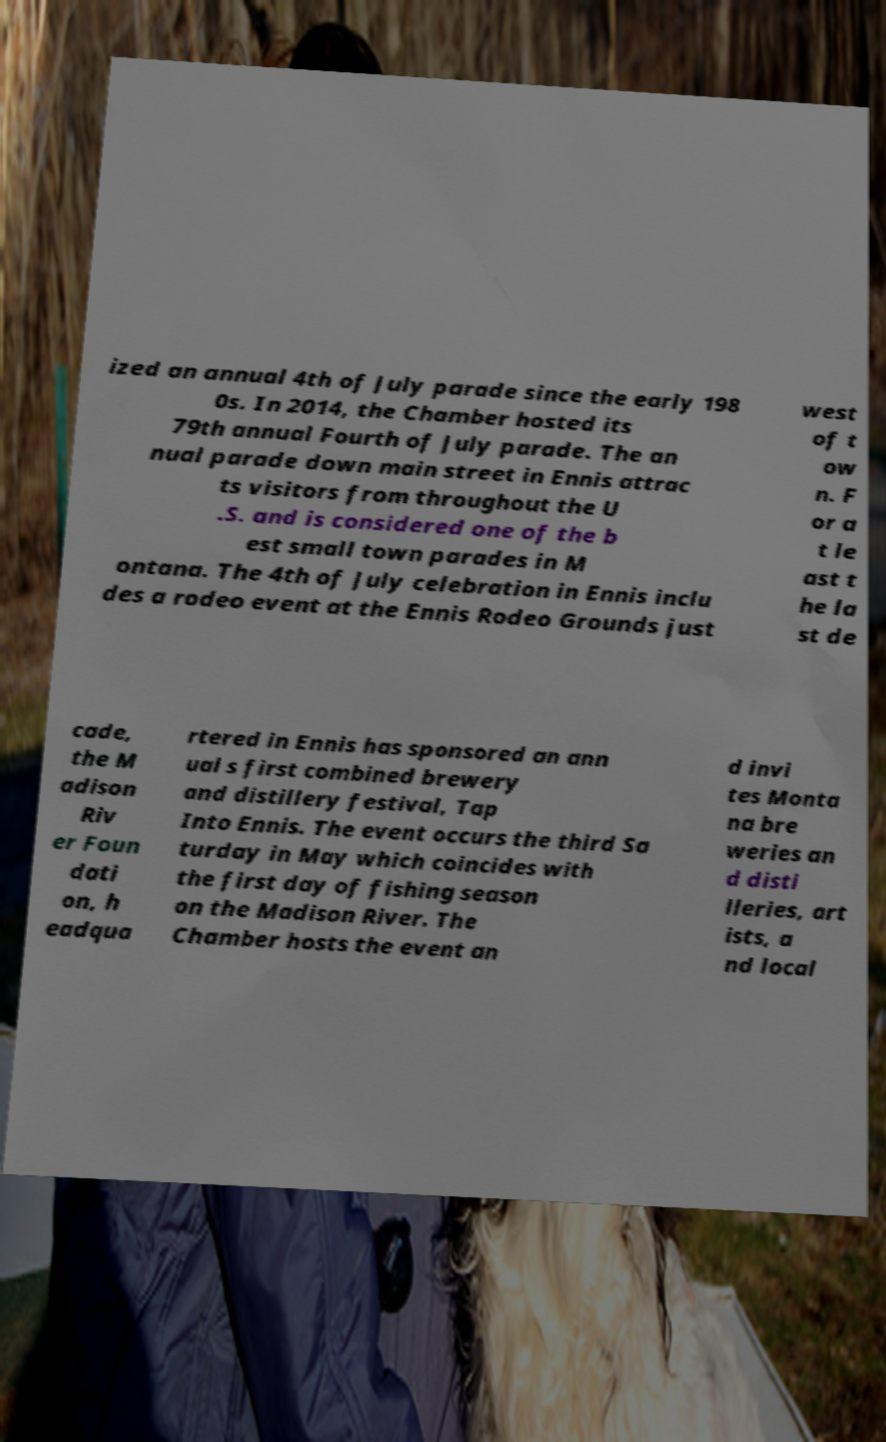Please read and relay the text visible in this image. What does it say? ized an annual 4th of July parade since the early 198 0s. In 2014, the Chamber hosted its 79th annual Fourth of July parade. The an nual parade down main street in Ennis attrac ts visitors from throughout the U .S. and is considered one of the b est small town parades in M ontana. The 4th of July celebration in Ennis inclu des a rodeo event at the Ennis Rodeo Grounds just west of t ow n. F or a t le ast t he la st de cade, the M adison Riv er Foun dati on, h eadqua rtered in Ennis has sponsored an ann ual s first combined brewery and distillery festival, Tap Into Ennis. The event occurs the third Sa turday in May which coincides with the first day of fishing season on the Madison River. The Chamber hosts the event an d invi tes Monta na bre weries an d disti lleries, art ists, a nd local 